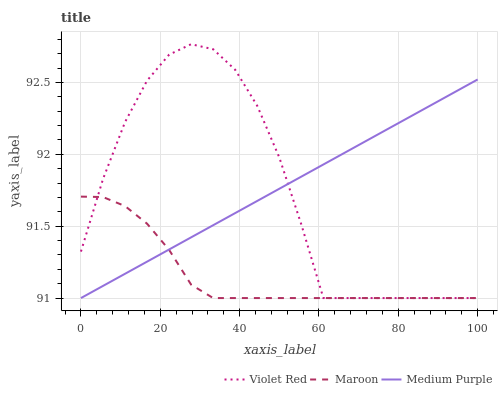Does Maroon have the minimum area under the curve?
Answer yes or no. Yes. Does Medium Purple have the maximum area under the curve?
Answer yes or no. Yes. Does Violet Red have the minimum area under the curve?
Answer yes or no. No. Does Violet Red have the maximum area under the curve?
Answer yes or no. No. Is Medium Purple the smoothest?
Answer yes or no. Yes. Is Violet Red the roughest?
Answer yes or no. Yes. Is Maroon the smoothest?
Answer yes or no. No. Is Maroon the roughest?
Answer yes or no. No. Does Medium Purple have the lowest value?
Answer yes or no. Yes. Does Violet Red have the highest value?
Answer yes or no. Yes. Does Maroon have the highest value?
Answer yes or no. No. Does Maroon intersect Medium Purple?
Answer yes or no. Yes. Is Maroon less than Medium Purple?
Answer yes or no. No. Is Maroon greater than Medium Purple?
Answer yes or no. No. 